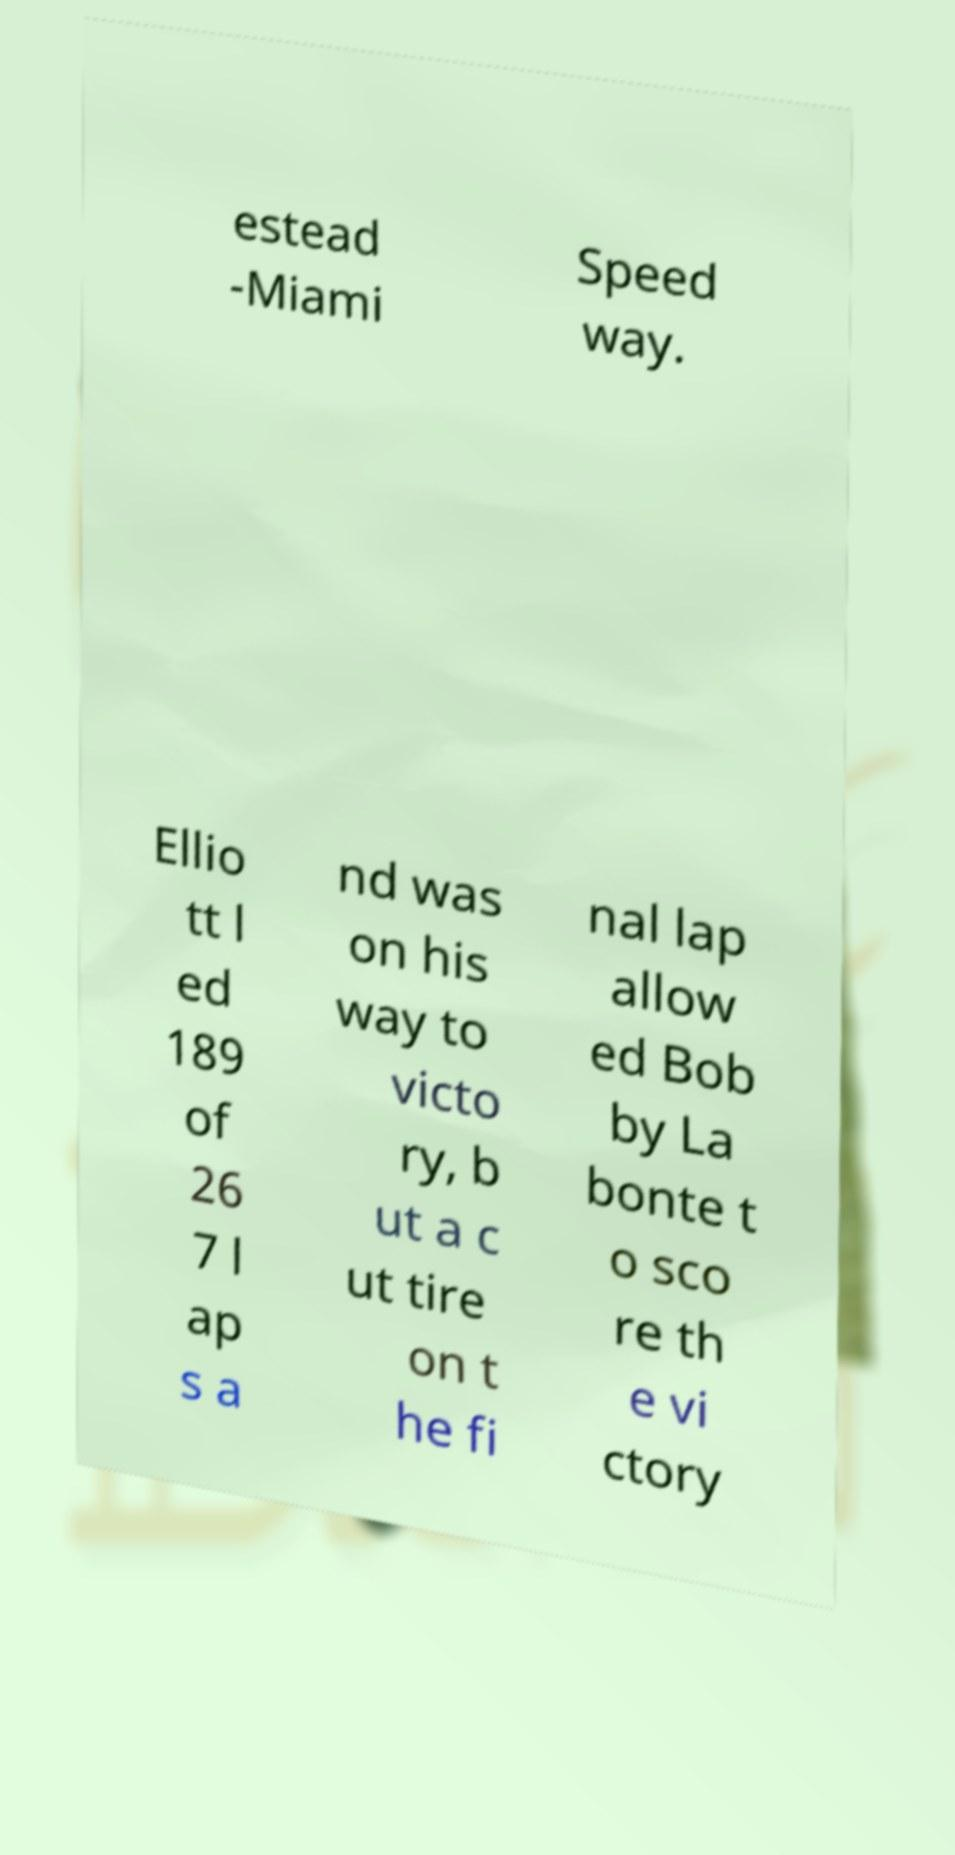For documentation purposes, I need the text within this image transcribed. Could you provide that? estead -Miami Speed way. Ellio tt l ed 189 of 26 7 l ap s a nd was on his way to victo ry, b ut a c ut tire on t he fi nal lap allow ed Bob by La bonte t o sco re th e vi ctory 